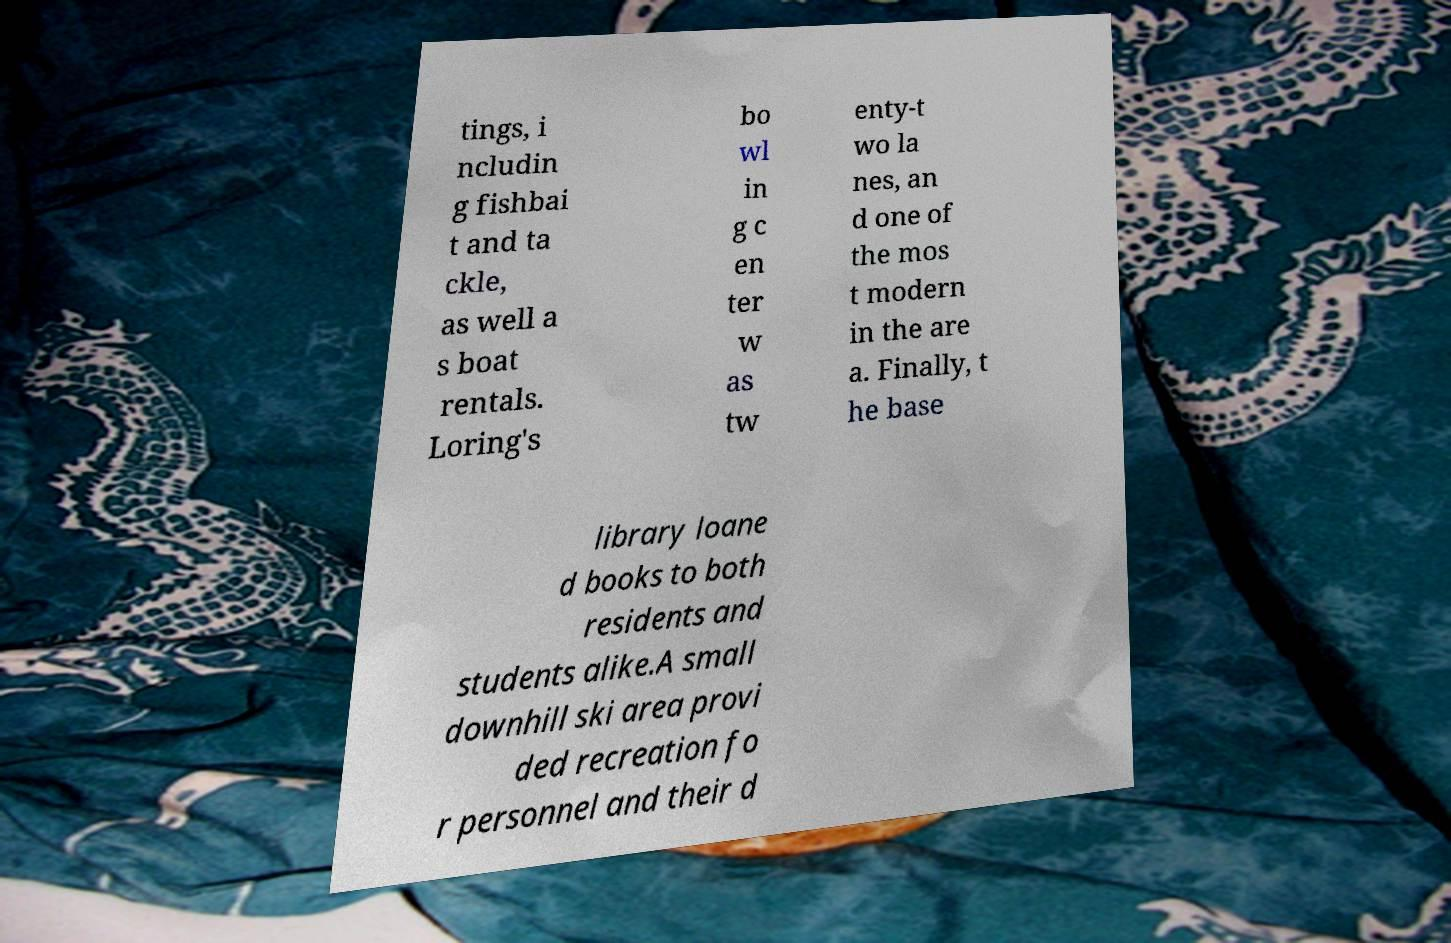Can you read and provide the text displayed in the image?This photo seems to have some interesting text. Can you extract and type it out for me? tings, i ncludin g fishbai t and ta ckle, as well a s boat rentals. Loring's bo wl in g c en ter w as tw enty-t wo la nes, an d one of the mos t modern in the are a. Finally, t he base library loane d books to both residents and students alike.A small downhill ski area provi ded recreation fo r personnel and their d 